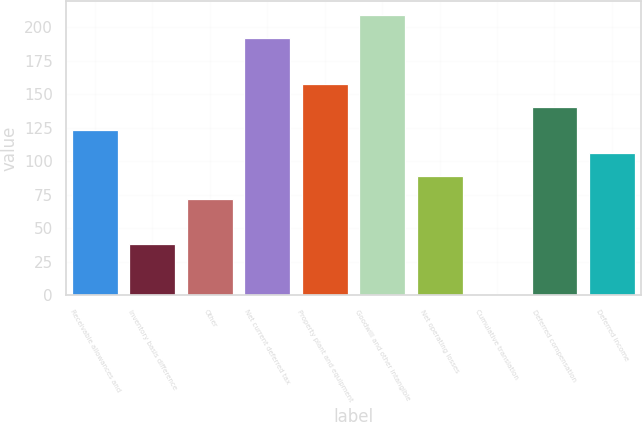Convert chart. <chart><loc_0><loc_0><loc_500><loc_500><bar_chart><fcel>Receivable allowances and<fcel>Inventory basis difference<fcel>Other<fcel>Net current deferred tax<fcel>Property plant and equipment<fcel>Goodwill and other intangible<fcel>Net operating losses<fcel>Cumulative translation<fcel>Deferred compensation<fcel>Deferred income<nl><fcel>123.34<fcel>37.89<fcel>72.07<fcel>191.7<fcel>157.52<fcel>208.79<fcel>89.16<fcel>1.1<fcel>140.43<fcel>106.25<nl></chart> 